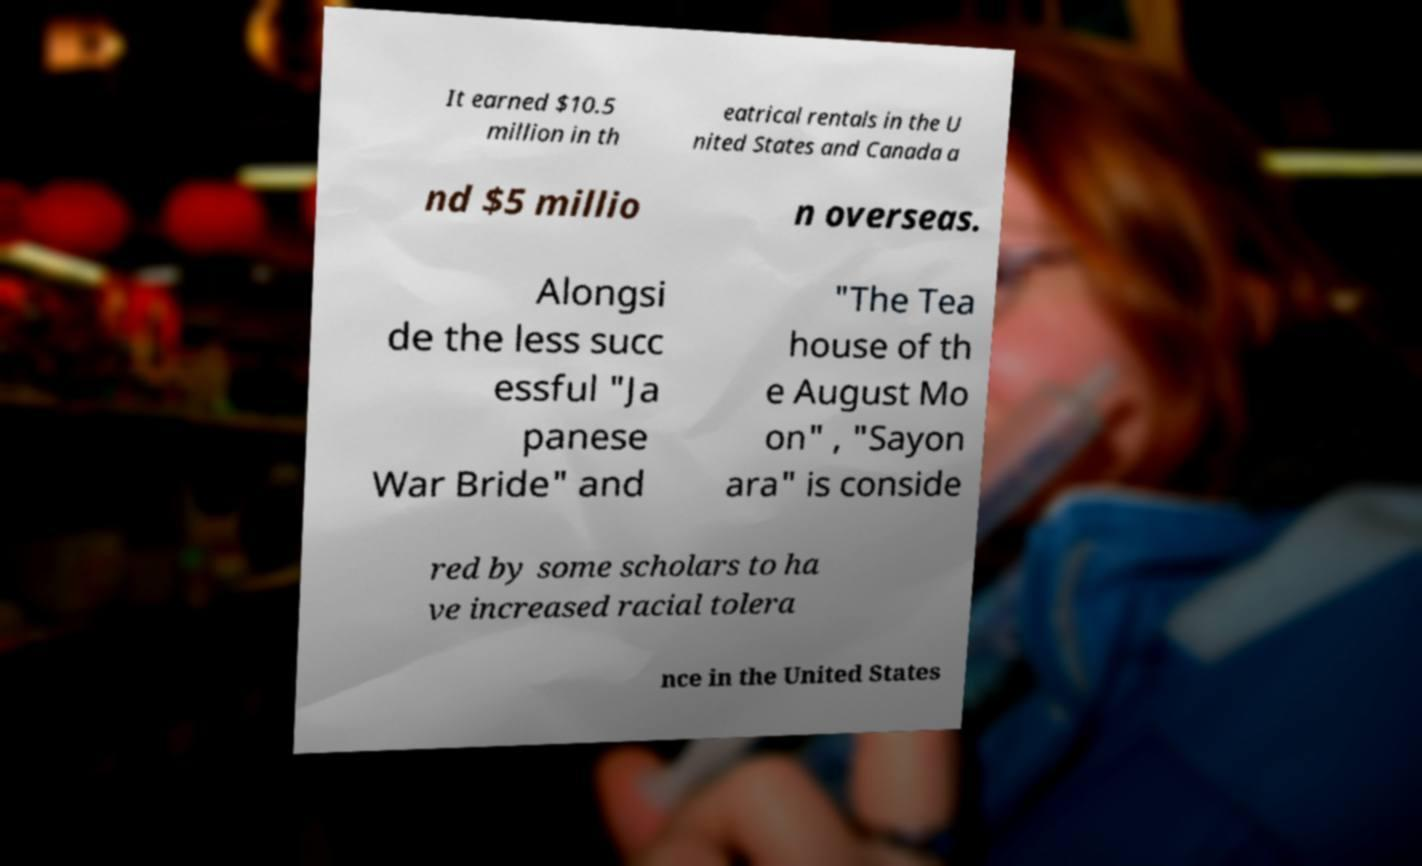I need the written content from this picture converted into text. Can you do that? It earned $10.5 million in th eatrical rentals in the U nited States and Canada a nd $5 millio n overseas. Alongsi de the less succ essful "Ja panese War Bride" and "The Tea house of th e August Mo on" , "Sayon ara" is conside red by some scholars to ha ve increased racial tolera nce in the United States 